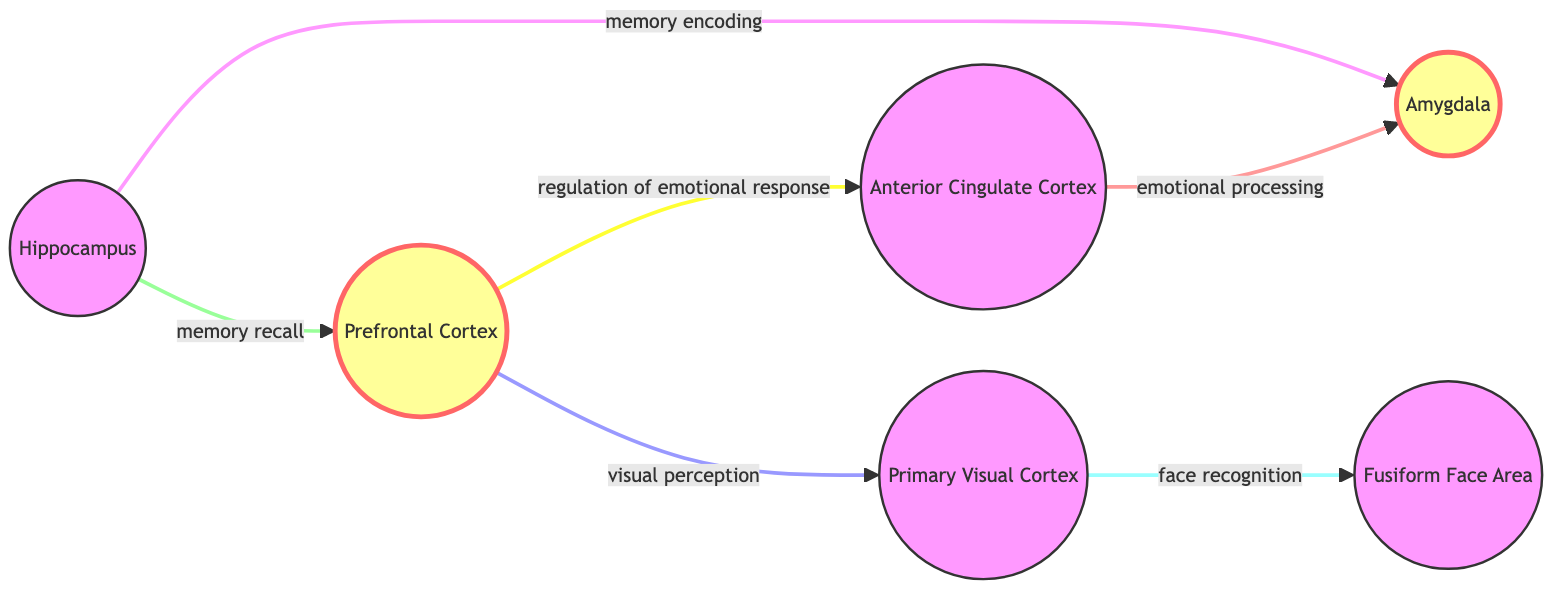What are the two regions highlighted in the diagram? The diagram designates the Prefrontal Cortex and the Amygdala as important regions. The specific nodes are affected by the custom class indicating their significance in the analysis.
Answer: Prefrontal Cortex, Amygdala How many brain regions are represented in the diagram? The diagram includes six nodes representing different brain regions: Prefrontal Cortex, Anterior Cingulate Cortex, Hippocampus, Fusiform Face Area, Primary Visual Cortex, and Amygdala, which totals to six.
Answer: 6 What is the connection between the Prefrontal Cortex and the Anterior Cingulate Cortex? The diagram shows that the Prefrontal Cortex connects to the Anterior Cingulate Cortex with the label “regulation of emotional response," indicating the nature of their interaction.
Answer: regulation of emotional response Which brain region is primarily involved in face recognition? According to the diagram, the connection from the Primary Visual Cortex to the Fusiform Face Area highlights the role of the Fusiform Face Area in face recognition.
Answer: Fusiform Face Area What relationship does the Hippocampus have with the Amygdala? The diagram describes two edges from the Hippocampus to the Amygdala: one labeled "memory encoding" and another labeled "memory recall," linking these two regions' functions.
Answer: memory encoding, memory recall Which two regions are linked by the edge labeled "emotional processing"? The Anterior Cingulate Cortex connects to the Amygdala with the label “emotional processing,” showing their relationship in the context of emotional functions.
Answer: Anterior Cingulate Cortex, Amygdala What is the total number of edges depicted in the diagram? By analyzing the connections displayed between the six nodes, there are a total of six edges that represent different interactions among the brain regions in the diagram.
Answer: 6 Which brain region contributes to visual perception? The diagram indicates that the Prefrontal Cortex is linked to the Primary Visual Cortex with the label "visual perception," showcasing its role in processing visual information.
Answer: Prefrontal Cortex 